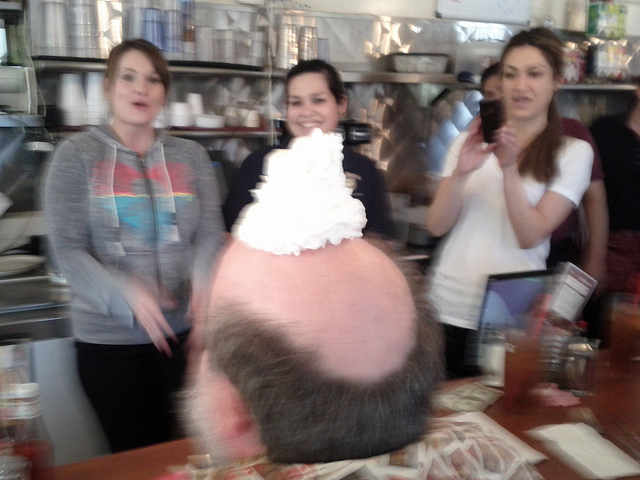What might have led to the moment captured in this photo? The moment likely stemmed from a spontaneous decision to add a touch of humor to the occasion. Perhaps the whipped cream was playfully placed during a birthday celebration or as an inside joke among the group. The woman's decision to take a photo suggests the moment was worth preserving, highlighting the joy and surprise associated with the act. 